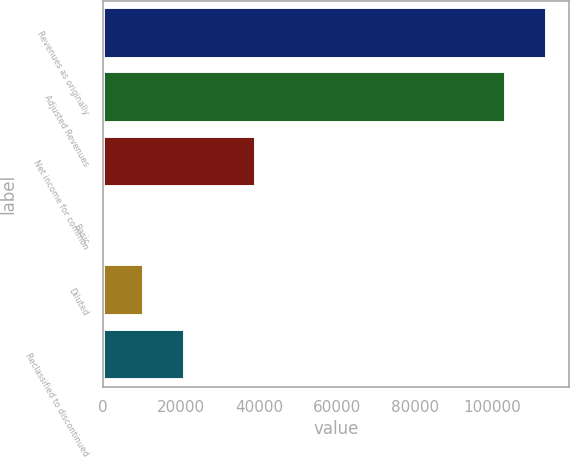<chart> <loc_0><loc_0><loc_500><loc_500><bar_chart><fcel>Revenues as originally<fcel>Adjusted Revenues<fcel>Net income for common<fcel>Basic<fcel>Diluted<fcel>Reclassified to discontinued<nl><fcel>114073<fcel>103510<fcel>39392<fcel>0.57<fcel>10563.8<fcel>21127<nl></chart> 